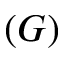Convert formula to latex. <formula><loc_0><loc_0><loc_500><loc_500>( G )</formula> 